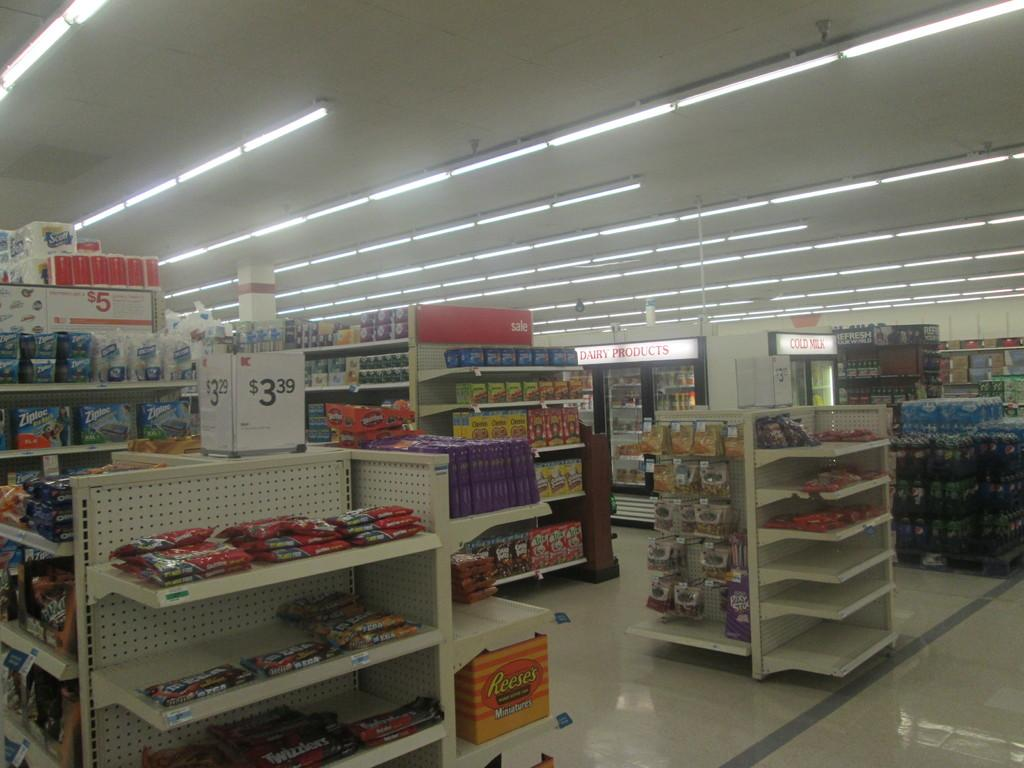<image>
Describe the image concisely. Empty store that has a Dairy Products section in the back. 